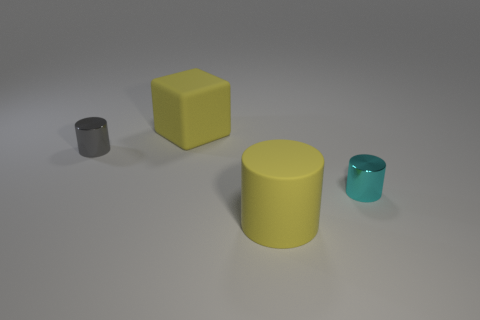How many things are large cylinders or tiny objects that are behind the cyan metal cylinder?
Give a very brief answer. 2. What is the material of the cyan object behind the big matte cylinder?
Ensure brevity in your answer.  Metal. What shape is the gray thing that is the same size as the cyan object?
Provide a short and direct response. Cylinder. Are there any big purple objects of the same shape as the cyan object?
Your answer should be compact. No. Is the material of the gray cylinder the same as the large thing behind the small cyan thing?
Provide a succinct answer. No. What is the material of the large yellow thing behind the large yellow rubber object in front of the small cyan shiny thing?
Ensure brevity in your answer.  Rubber. Is the number of yellow cylinders that are behind the rubber cylinder greater than the number of tiny objects?
Offer a terse response. No. Are there any metallic things?
Keep it short and to the point. Yes. What color is the object that is in front of the small cyan shiny cylinder?
Ensure brevity in your answer.  Yellow. There is a cyan object that is the same size as the gray metal thing; what is it made of?
Offer a very short reply. Metal. 